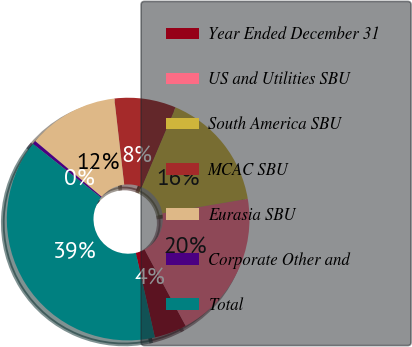Convert chart. <chart><loc_0><loc_0><loc_500><loc_500><pie_chart><fcel>Year Ended December 31<fcel>US and Utilities SBU<fcel>South America SBU<fcel>MCAC SBU<fcel>Eurasia SBU<fcel>Corporate Other and<fcel>Total<nl><fcel>4.33%<fcel>19.81%<fcel>15.94%<fcel>8.2%<fcel>12.07%<fcel>0.47%<fcel>39.16%<nl></chart> 